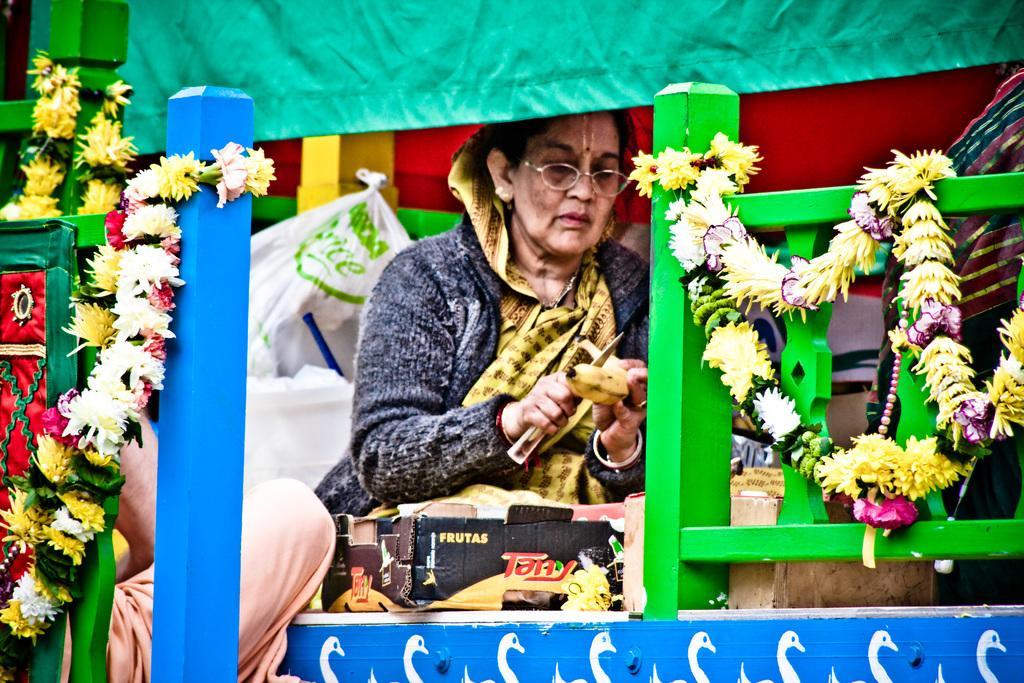Describe this image in one or two sentences. In front of the image there are railings with flower garlands. Behind them there is a lady sitting and she kept spectacles. She is holding a banana in her hands. In front of her there are few objects and behind her also there is a plastic bag and some other things. At the top of the image there is a cloth hanging.  